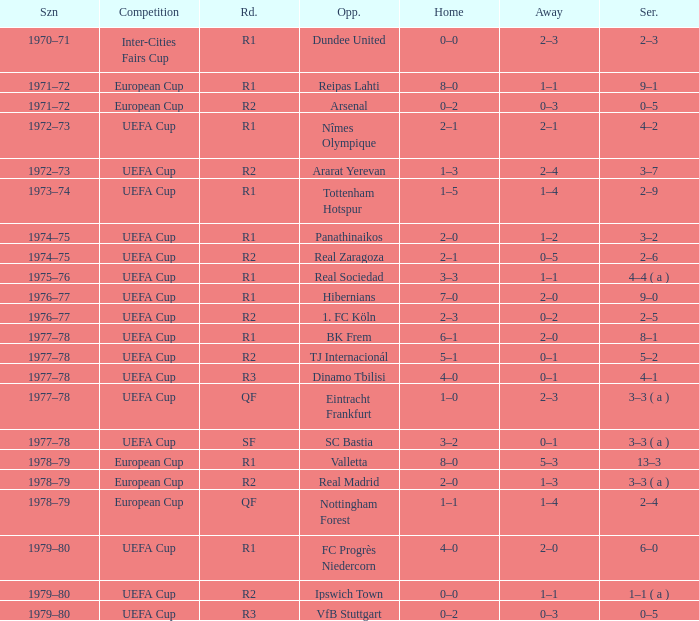Which Home has a Competition of european cup, and a Round of qf? 1–1. 